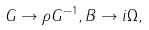<formula> <loc_0><loc_0><loc_500><loc_500>G \rightarrow \rho G ^ { - 1 } , B \rightarrow i \Omega ,</formula> 